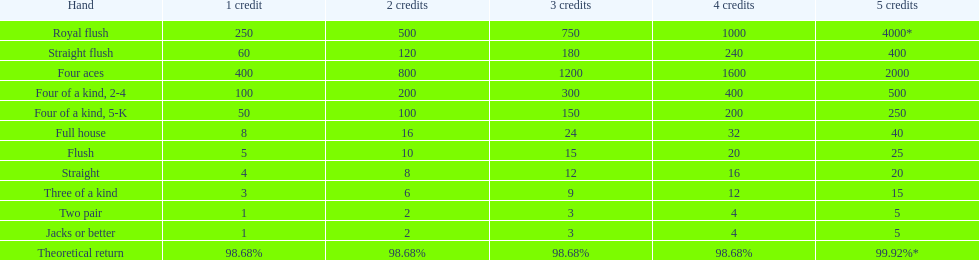How many straight wins at 3 credits equals one straight flush win at two credits? 10. 